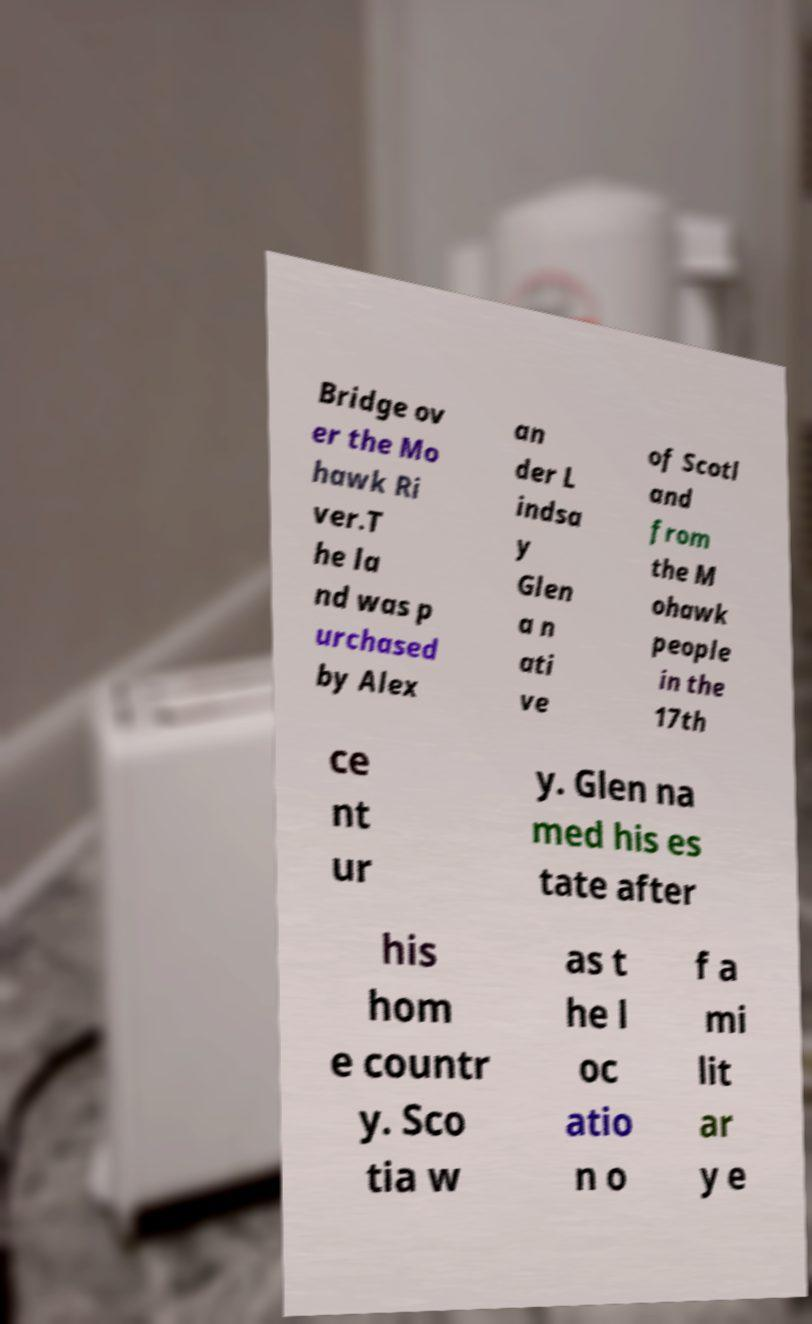Could you assist in decoding the text presented in this image and type it out clearly? Bridge ov er the Mo hawk Ri ver.T he la nd was p urchased by Alex an der L indsa y Glen a n ati ve of Scotl and from the M ohawk people in the 17th ce nt ur y. Glen na med his es tate after his hom e countr y. Sco tia w as t he l oc atio n o f a mi lit ar y e 